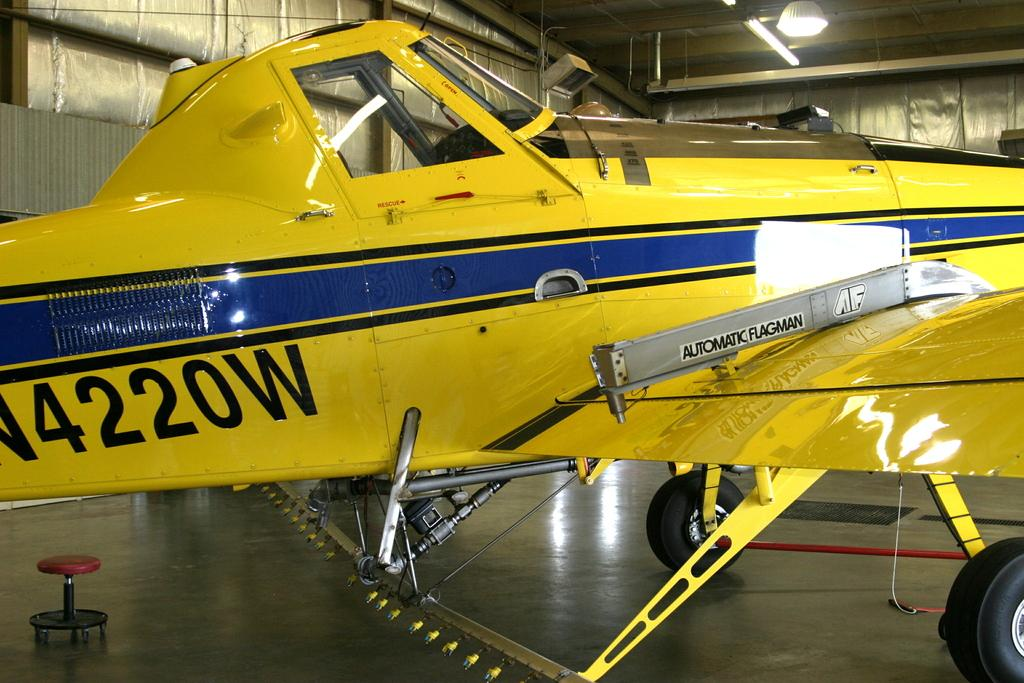<image>
Share a concise interpretation of the image provided. A small yellow plane on which there appears numbers 4220 followed by the letter W. 